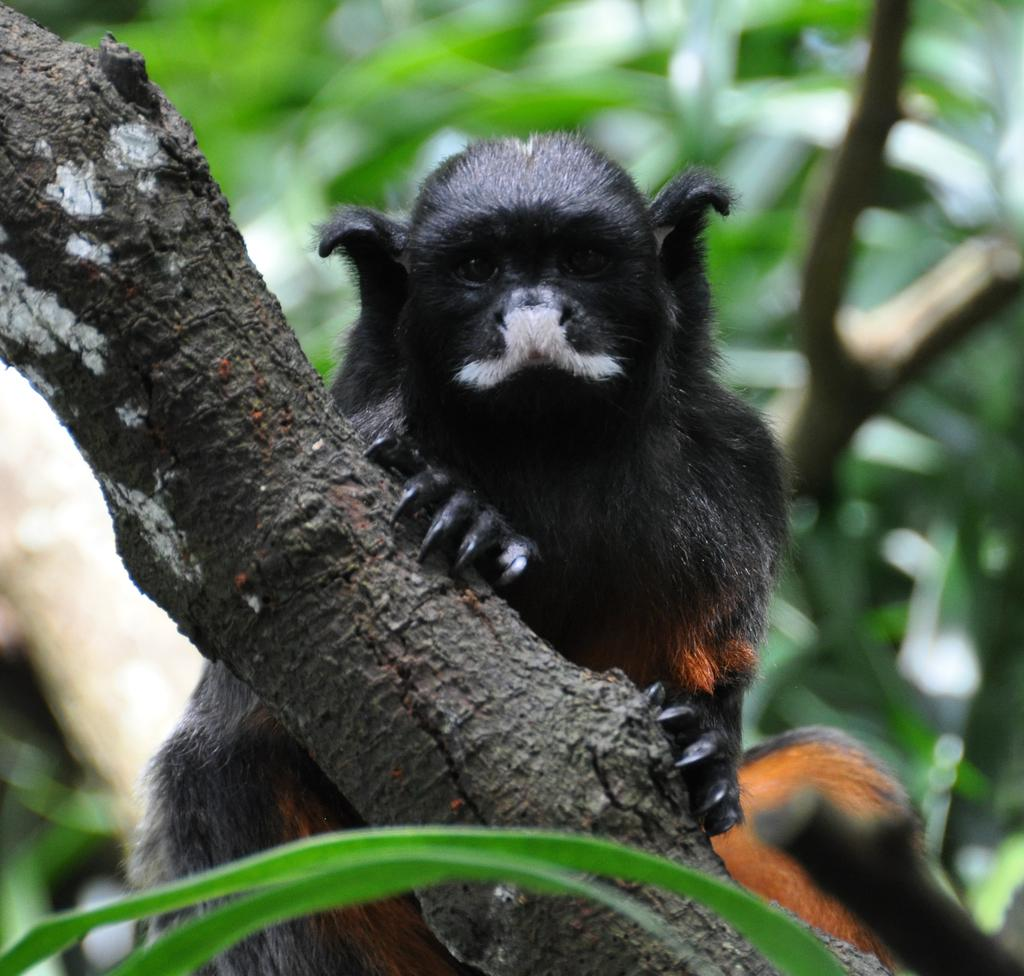What type of animal can be seen in the image? There is an animal in the image, but its specific type cannot be determined from the provided facts. Where is the animal located in the image? The animal is on the branch of a tree. What can be said about the background of the image? The background of the image is blurred. What type of whip is the animal using to move around in the image? There is no whip present in the image, and the animal is not moving around. 